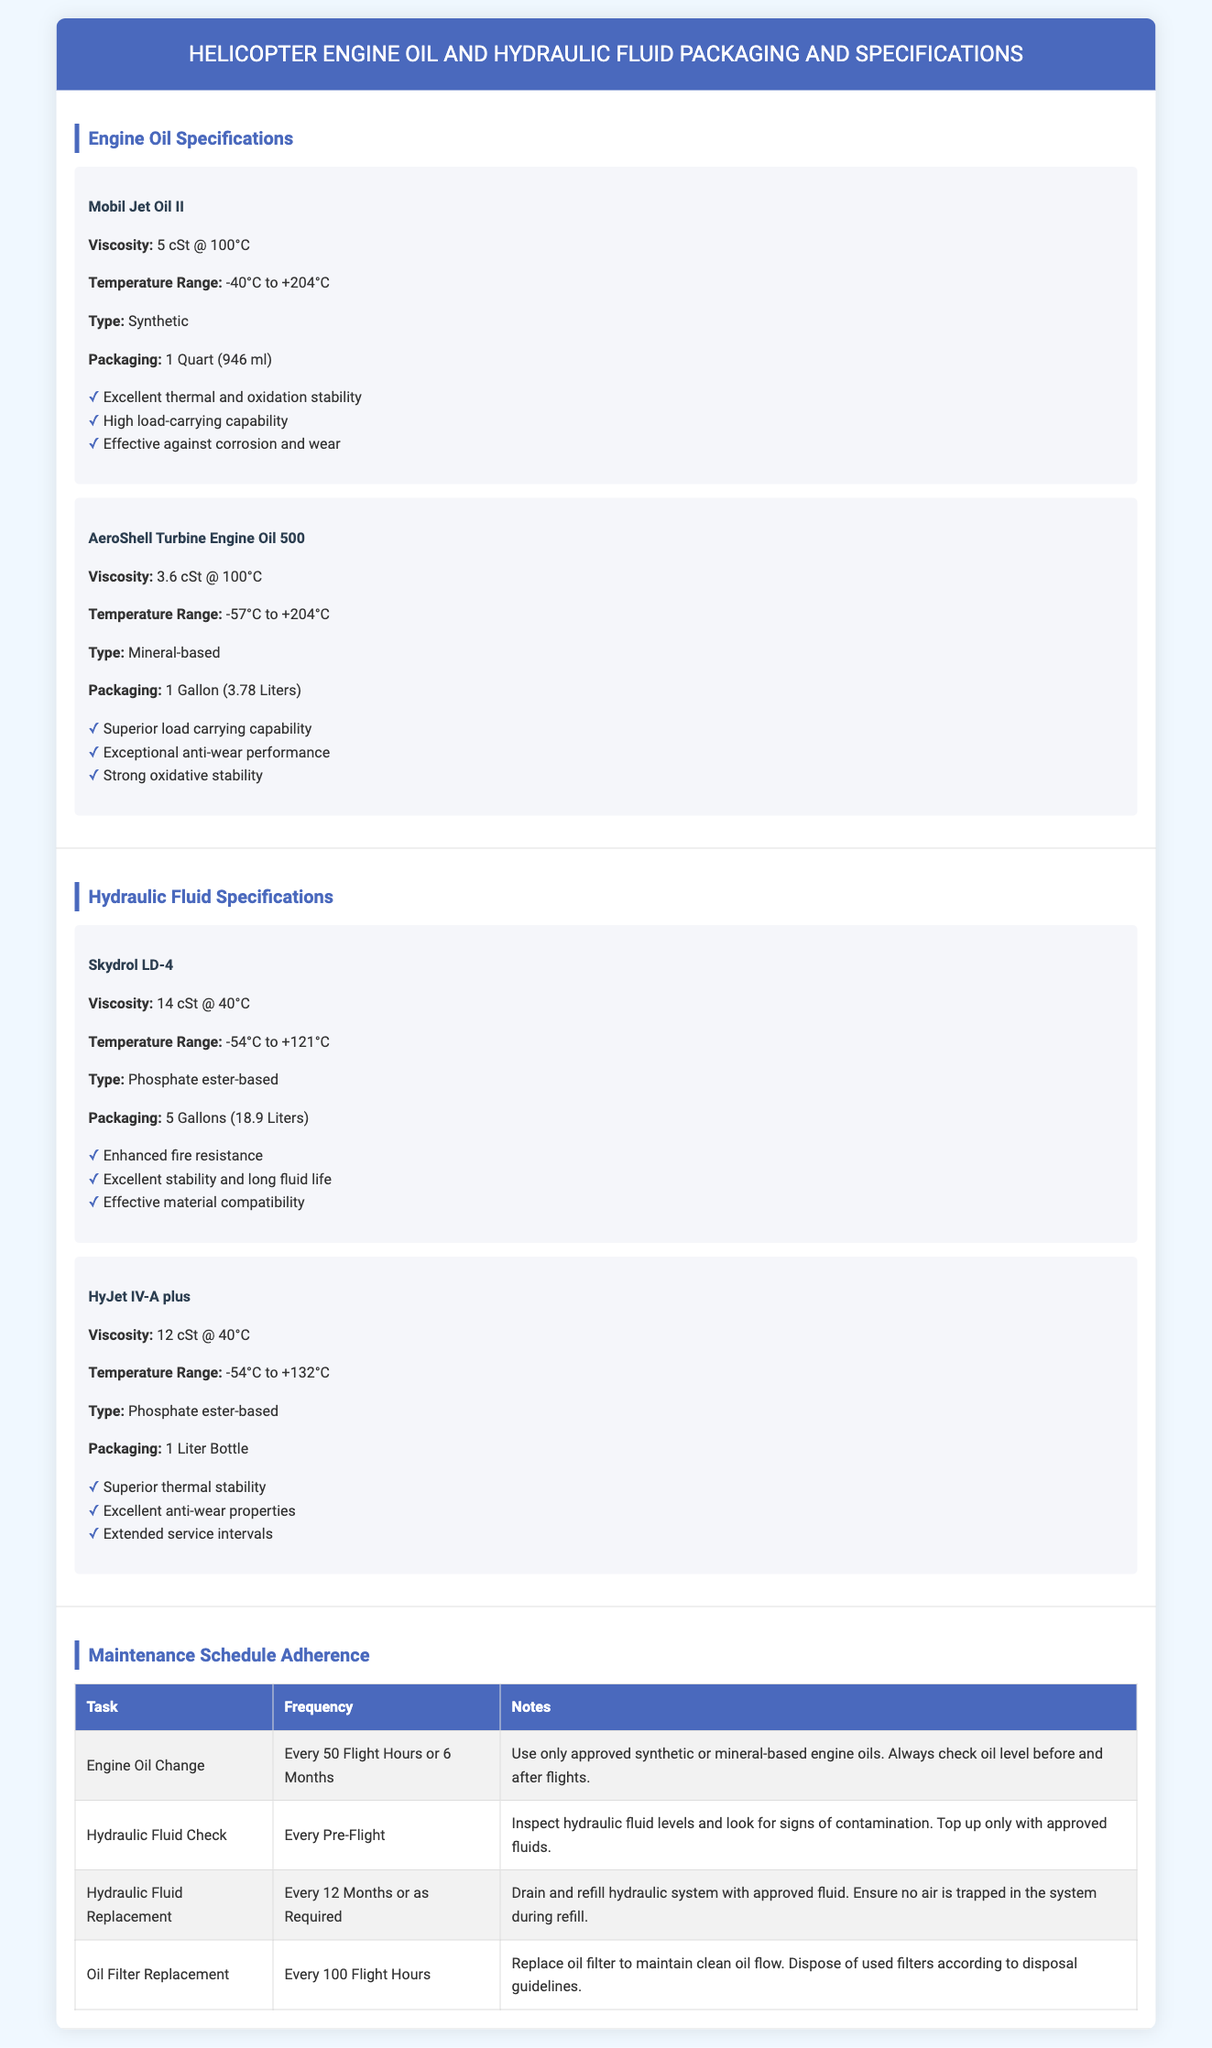What is the viscosity of Mobil Jet Oil II? The viscosity of Mobil Jet Oil II is listed as 5 cSt at 100°C according to the specifications in the document.
Answer: 5 cSt @ 100°C What is the packaging size of HyJet IV-A plus? The packaging size for HyJet IV-A plus is specified as 1 Liter Bottle in the document.
Answer: 1 Liter Bottle What is the temperature range for AeroShell Turbine Engine Oil 500? The temperature range provided for AeroShell Turbine Engine Oil 500 is between -57°C to +204°C according to the document.
Answer: -57°C to +204°C How often should the engine oil be changed? The document states the engine oil should be changed every 50 flight hours or 6 months, making it a specific adherence requirement.
Answer: Every 50 Flight Hours or 6 Months What type of hydraulic fluid is Skydrol LD-4? The type of hydraulic fluid specified for Skydrol LD-4 is phosphate ester-based, as outlined in the document.
Answer: Phosphate ester-based What is the frequency for checking hydraulic fluid levels? The document indicates that the frequency for checking hydraulic fluid levels is every pre-flight, which is an important maintenance task.
Answer: Every Pre-Flight What should be used to top up hydraulic fluid levels? According to the document, only approved fluids should be used to top up hydraulic fluid levels, emphasizing safety and compliance.
Answer: Approved fluids How often should the oil filter be replaced? The document recommends replacing the oil filter every 100 flight hours, indicating a specific maintenance timeline.
Answer: Every 100 Flight Hours 